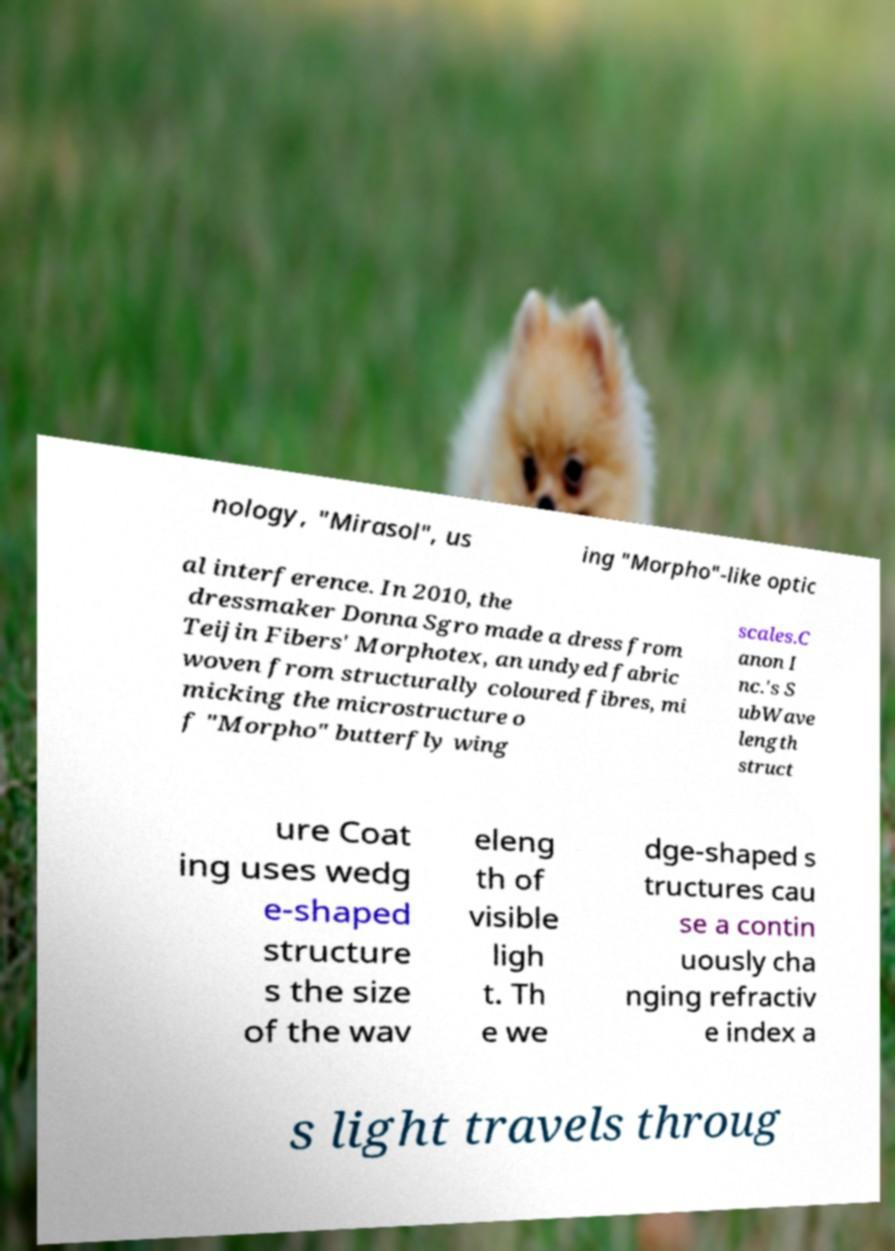Could you extract and type out the text from this image? nology, "Mirasol", us ing "Morpho"-like optic al interference. In 2010, the dressmaker Donna Sgro made a dress from Teijin Fibers' Morphotex, an undyed fabric woven from structurally coloured fibres, mi micking the microstructure o f "Morpho" butterfly wing scales.C anon I nc.'s S ubWave length struct ure Coat ing uses wedg e-shaped structure s the size of the wav eleng th of visible ligh t. Th e we dge-shaped s tructures cau se a contin uously cha nging refractiv e index a s light travels throug 